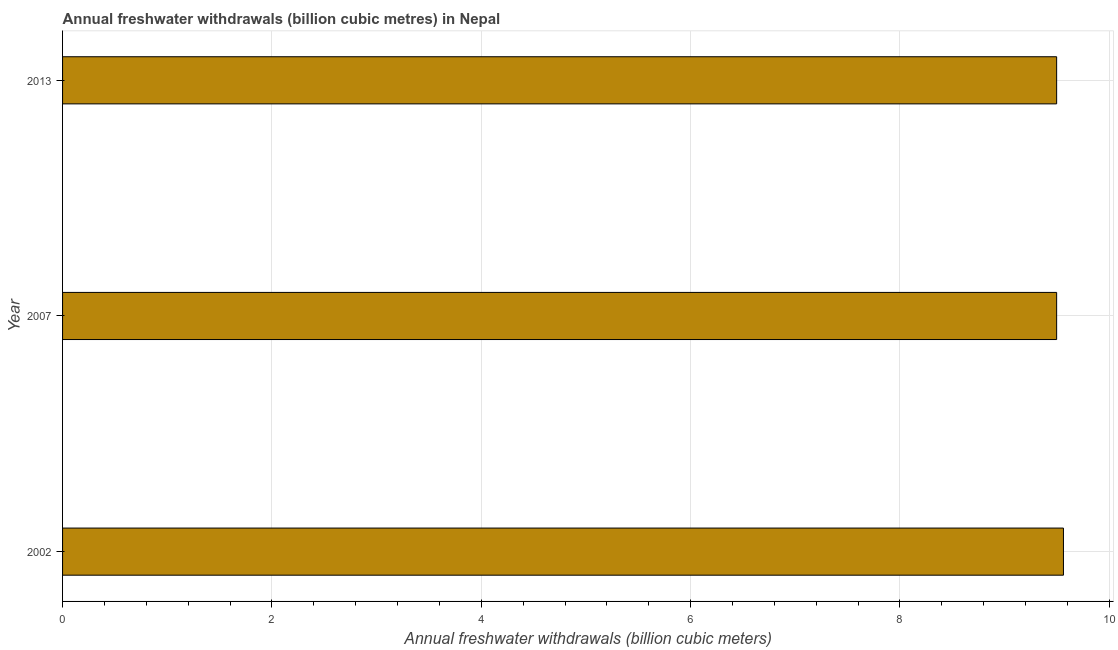Does the graph contain any zero values?
Offer a terse response. No. Does the graph contain grids?
Your answer should be compact. Yes. What is the title of the graph?
Your answer should be very brief. Annual freshwater withdrawals (billion cubic metres) in Nepal. What is the label or title of the X-axis?
Offer a very short reply. Annual freshwater withdrawals (billion cubic meters). What is the label or title of the Y-axis?
Provide a short and direct response. Year. What is the annual freshwater withdrawals in 2007?
Your response must be concise. 9.5. Across all years, what is the maximum annual freshwater withdrawals?
Your answer should be compact. 9.56. Across all years, what is the minimum annual freshwater withdrawals?
Provide a succinct answer. 9.5. In which year was the annual freshwater withdrawals maximum?
Your answer should be compact. 2002. What is the sum of the annual freshwater withdrawals?
Provide a short and direct response. 28.56. What is the difference between the annual freshwater withdrawals in 2002 and 2007?
Ensure brevity in your answer.  0.07. What is the average annual freshwater withdrawals per year?
Your answer should be very brief. 9.52. What is the median annual freshwater withdrawals?
Provide a short and direct response. 9.5. In how many years, is the annual freshwater withdrawals greater than 4.4 billion cubic meters?
Offer a terse response. 3. Do a majority of the years between 2002 and 2007 (inclusive) have annual freshwater withdrawals greater than 5.2 billion cubic meters?
Offer a terse response. Yes. What is the ratio of the annual freshwater withdrawals in 2002 to that in 2007?
Offer a very short reply. 1.01. Is the annual freshwater withdrawals in 2007 less than that in 2013?
Provide a succinct answer. No. Is the difference between the annual freshwater withdrawals in 2002 and 2007 greater than the difference between any two years?
Your answer should be very brief. Yes. What is the difference between the highest and the second highest annual freshwater withdrawals?
Ensure brevity in your answer.  0.07. In how many years, is the annual freshwater withdrawals greater than the average annual freshwater withdrawals taken over all years?
Offer a terse response. 1. What is the difference between two consecutive major ticks on the X-axis?
Provide a short and direct response. 2. What is the Annual freshwater withdrawals (billion cubic meters) of 2002?
Provide a short and direct response. 9.56. What is the Annual freshwater withdrawals (billion cubic meters) of 2007?
Your response must be concise. 9.5. What is the Annual freshwater withdrawals (billion cubic meters) of 2013?
Your answer should be very brief. 9.5. What is the difference between the Annual freshwater withdrawals (billion cubic meters) in 2002 and 2007?
Make the answer very short. 0.07. What is the difference between the Annual freshwater withdrawals (billion cubic meters) in 2002 and 2013?
Ensure brevity in your answer.  0.07. What is the difference between the Annual freshwater withdrawals (billion cubic meters) in 2007 and 2013?
Give a very brief answer. 0. What is the ratio of the Annual freshwater withdrawals (billion cubic meters) in 2002 to that in 2007?
Make the answer very short. 1.01. What is the ratio of the Annual freshwater withdrawals (billion cubic meters) in 2007 to that in 2013?
Your answer should be very brief. 1. 